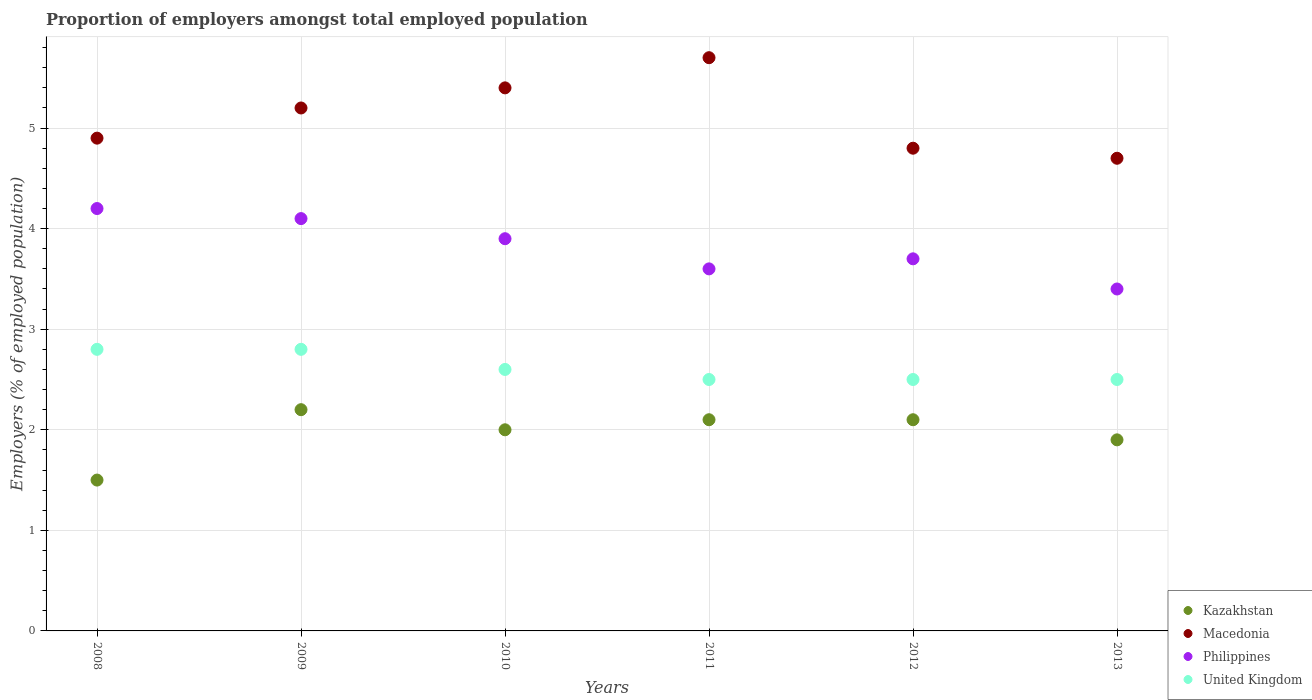How many different coloured dotlines are there?
Your answer should be very brief. 4. Is the number of dotlines equal to the number of legend labels?
Make the answer very short. Yes. What is the proportion of employers in United Kingdom in 2010?
Give a very brief answer. 2.6. Across all years, what is the maximum proportion of employers in Kazakhstan?
Provide a succinct answer. 2.2. Across all years, what is the minimum proportion of employers in United Kingdom?
Keep it short and to the point. 2.5. In which year was the proportion of employers in Kazakhstan maximum?
Your answer should be compact. 2009. What is the total proportion of employers in United Kingdom in the graph?
Keep it short and to the point. 15.7. What is the difference between the proportion of employers in Macedonia in 2011 and that in 2013?
Your answer should be very brief. 1. What is the difference between the proportion of employers in United Kingdom in 2013 and the proportion of employers in Philippines in 2009?
Your answer should be compact. -1.6. What is the average proportion of employers in Philippines per year?
Keep it short and to the point. 3.82. In the year 2008, what is the difference between the proportion of employers in Kazakhstan and proportion of employers in Macedonia?
Keep it short and to the point. -3.4. In how many years, is the proportion of employers in Philippines greater than 1.6 %?
Your response must be concise. 6. What is the ratio of the proportion of employers in Philippines in 2008 to that in 2012?
Offer a terse response. 1.14. What is the difference between the highest and the second highest proportion of employers in Macedonia?
Your response must be concise. 0.3. What is the difference between the highest and the lowest proportion of employers in Macedonia?
Your response must be concise. 1. In how many years, is the proportion of employers in Kazakhstan greater than the average proportion of employers in Kazakhstan taken over all years?
Make the answer very short. 4. Is the sum of the proportion of employers in Macedonia in 2008 and 2011 greater than the maximum proportion of employers in Philippines across all years?
Ensure brevity in your answer.  Yes. Is it the case that in every year, the sum of the proportion of employers in Macedonia and proportion of employers in United Kingdom  is greater than the sum of proportion of employers in Kazakhstan and proportion of employers in Philippines?
Provide a succinct answer. No. Does the proportion of employers in Kazakhstan monotonically increase over the years?
Ensure brevity in your answer.  No. Is the proportion of employers in United Kingdom strictly greater than the proportion of employers in Kazakhstan over the years?
Offer a very short reply. Yes. Is the proportion of employers in Macedonia strictly less than the proportion of employers in United Kingdom over the years?
Provide a succinct answer. No. What is the difference between two consecutive major ticks on the Y-axis?
Offer a terse response. 1. Where does the legend appear in the graph?
Your answer should be compact. Bottom right. What is the title of the graph?
Provide a succinct answer. Proportion of employers amongst total employed population. What is the label or title of the X-axis?
Keep it short and to the point. Years. What is the label or title of the Y-axis?
Offer a very short reply. Employers (% of employed population). What is the Employers (% of employed population) of Macedonia in 2008?
Offer a terse response. 4.9. What is the Employers (% of employed population) in Philippines in 2008?
Offer a terse response. 4.2. What is the Employers (% of employed population) in United Kingdom in 2008?
Your answer should be very brief. 2.8. What is the Employers (% of employed population) in Kazakhstan in 2009?
Provide a succinct answer. 2.2. What is the Employers (% of employed population) of Macedonia in 2009?
Provide a short and direct response. 5.2. What is the Employers (% of employed population) of Philippines in 2009?
Make the answer very short. 4.1. What is the Employers (% of employed population) of United Kingdom in 2009?
Keep it short and to the point. 2.8. What is the Employers (% of employed population) of Kazakhstan in 2010?
Your answer should be very brief. 2. What is the Employers (% of employed population) in Macedonia in 2010?
Your response must be concise. 5.4. What is the Employers (% of employed population) in Philippines in 2010?
Ensure brevity in your answer.  3.9. What is the Employers (% of employed population) in United Kingdom in 2010?
Your answer should be very brief. 2.6. What is the Employers (% of employed population) of Kazakhstan in 2011?
Ensure brevity in your answer.  2.1. What is the Employers (% of employed population) in Macedonia in 2011?
Your response must be concise. 5.7. What is the Employers (% of employed population) in Philippines in 2011?
Your answer should be compact. 3.6. What is the Employers (% of employed population) of United Kingdom in 2011?
Provide a succinct answer. 2.5. What is the Employers (% of employed population) in Kazakhstan in 2012?
Your response must be concise. 2.1. What is the Employers (% of employed population) of Macedonia in 2012?
Provide a short and direct response. 4.8. What is the Employers (% of employed population) of Philippines in 2012?
Provide a short and direct response. 3.7. What is the Employers (% of employed population) of Kazakhstan in 2013?
Your answer should be compact. 1.9. What is the Employers (% of employed population) of Macedonia in 2013?
Ensure brevity in your answer.  4.7. What is the Employers (% of employed population) of Philippines in 2013?
Keep it short and to the point. 3.4. What is the Employers (% of employed population) of United Kingdom in 2013?
Your answer should be compact. 2.5. Across all years, what is the maximum Employers (% of employed population) of Kazakhstan?
Make the answer very short. 2.2. Across all years, what is the maximum Employers (% of employed population) of Macedonia?
Your answer should be compact. 5.7. Across all years, what is the maximum Employers (% of employed population) of Philippines?
Keep it short and to the point. 4.2. Across all years, what is the maximum Employers (% of employed population) of United Kingdom?
Provide a succinct answer. 2.8. Across all years, what is the minimum Employers (% of employed population) of Kazakhstan?
Provide a succinct answer. 1.5. Across all years, what is the minimum Employers (% of employed population) in Macedonia?
Make the answer very short. 4.7. Across all years, what is the minimum Employers (% of employed population) in Philippines?
Ensure brevity in your answer.  3.4. Across all years, what is the minimum Employers (% of employed population) in United Kingdom?
Give a very brief answer. 2.5. What is the total Employers (% of employed population) in Kazakhstan in the graph?
Provide a short and direct response. 11.8. What is the total Employers (% of employed population) of Macedonia in the graph?
Provide a succinct answer. 30.7. What is the total Employers (% of employed population) of Philippines in the graph?
Ensure brevity in your answer.  22.9. What is the difference between the Employers (% of employed population) in United Kingdom in 2008 and that in 2009?
Provide a succinct answer. 0. What is the difference between the Employers (% of employed population) of Kazakhstan in 2008 and that in 2010?
Offer a terse response. -0.5. What is the difference between the Employers (% of employed population) of Macedonia in 2008 and that in 2010?
Keep it short and to the point. -0.5. What is the difference between the Employers (% of employed population) of United Kingdom in 2008 and that in 2010?
Make the answer very short. 0.2. What is the difference between the Employers (% of employed population) in Macedonia in 2008 and that in 2011?
Your answer should be very brief. -0.8. What is the difference between the Employers (% of employed population) of Philippines in 2008 and that in 2011?
Make the answer very short. 0.6. What is the difference between the Employers (% of employed population) of United Kingdom in 2008 and that in 2011?
Make the answer very short. 0.3. What is the difference between the Employers (% of employed population) of Kazakhstan in 2008 and that in 2013?
Keep it short and to the point. -0.4. What is the difference between the Employers (% of employed population) in United Kingdom in 2008 and that in 2013?
Your answer should be compact. 0.3. What is the difference between the Employers (% of employed population) of Kazakhstan in 2009 and that in 2010?
Offer a terse response. 0.2. What is the difference between the Employers (% of employed population) in Macedonia in 2009 and that in 2010?
Keep it short and to the point. -0.2. What is the difference between the Employers (% of employed population) in Philippines in 2009 and that in 2010?
Your answer should be very brief. 0.2. What is the difference between the Employers (% of employed population) in United Kingdom in 2009 and that in 2010?
Make the answer very short. 0.2. What is the difference between the Employers (% of employed population) of Philippines in 2009 and that in 2011?
Keep it short and to the point. 0.5. What is the difference between the Employers (% of employed population) in Macedonia in 2009 and that in 2012?
Make the answer very short. 0.4. What is the difference between the Employers (% of employed population) of Philippines in 2009 and that in 2012?
Your answer should be compact. 0.4. What is the difference between the Employers (% of employed population) of Kazakhstan in 2009 and that in 2013?
Make the answer very short. 0.3. What is the difference between the Employers (% of employed population) in Kazakhstan in 2010 and that in 2011?
Your answer should be compact. -0.1. What is the difference between the Employers (% of employed population) of Macedonia in 2010 and that in 2012?
Provide a succinct answer. 0.6. What is the difference between the Employers (% of employed population) of United Kingdom in 2010 and that in 2012?
Your answer should be compact. 0.1. What is the difference between the Employers (% of employed population) of Kazakhstan in 2010 and that in 2013?
Provide a succinct answer. 0.1. What is the difference between the Employers (% of employed population) of Macedonia in 2010 and that in 2013?
Your answer should be compact. 0.7. What is the difference between the Employers (% of employed population) of United Kingdom in 2010 and that in 2013?
Offer a very short reply. 0.1. What is the difference between the Employers (% of employed population) of Kazakhstan in 2011 and that in 2012?
Provide a succinct answer. 0. What is the difference between the Employers (% of employed population) in Kazakhstan in 2011 and that in 2013?
Make the answer very short. 0.2. What is the difference between the Employers (% of employed population) of Kazakhstan in 2012 and that in 2013?
Offer a very short reply. 0.2. What is the difference between the Employers (% of employed population) of Kazakhstan in 2008 and the Employers (% of employed population) of Macedonia in 2009?
Keep it short and to the point. -3.7. What is the difference between the Employers (% of employed population) in Kazakhstan in 2008 and the Employers (% of employed population) in Philippines in 2009?
Provide a succinct answer. -2.6. What is the difference between the Employers (% of employed population) of Kazakhstan in 2008 and the Employers (% of employed population) of United Kingdom in 2009?
Your answer should be very brief. -1.3. What is the difference between the Employers (% of employed population) of Macedonia in 2008 and the Employers (% of employed population) of Philippines in 2009?
Your response must be concise. 0.8. What is the difference between the Employers (% of employed population) in Macedonia in 2008 and the Employers (% of employed population) in United Kingdom in 2009?
Keep it short and to the point. 2.1. What is the difference between the Employers (% of employed population) of Kazakhstan in 2008 and the Employers (% of employed population) of Macedonia in 2010?
Your answer should be compact. -3.9. What is the difference between the Employers (% of employed population) of Kazakhstan in 2008 and the Employers (% of employed population) of United Kingdom in 2010?
Offer a very short reply. -1.1. What is the difference between the Employers (% of employed population) of Kazakhstan in 2008 and the Employers (% of employed population) of Macedonia in 2011?
Provide a succinct answer. -4.2. What is the difference between the Employers (% of employed population) in Kazakhstan in 2008 and the Employers (% of employed population) in United Kingdom in 2011?
Give a very brief answer. -1. What is the difference between the Employers (% of employed population) of Kazakhstan in 2008 and the Employers (% of employed population) of Philippines in 2012?
Make the answer very short. -2.2. What is the difference between the Employers (% of employed population) of Macedonia in 2008 and the Employers (% of employed population) of United Kingdom in 2012?
Provide a short and direct response. 2.4. What is the difference between the Employers (% of employed population) of Philippines in 2008 and the Employers (% of employed population) of United Kingdom in 2012?
Your answer should be very brief. 1.7. What is the difference between the Employers (% of employed population) of Kazakhstan in 2008 and the Employers (% of employed population) of Macedonia in 2013?
Your response must be concise. -3.2. What is the difference between the Employers (% of employed population) of Kazakhstan in 2008 and the Employers (% of employed population) of Philippines in 2013?
Your answer should be very brief. -1.9. What is the difference between the Employers (% of employed population) in Kazakhstan in 2009 and the Employers (% of employed population) in Philippines in 2010?
Ensure brevity in your answer.  -1.7. What is the difference between the Employers (% of employed population) in Macedonia in 2009 and the Employers (% of employed population) in Philippines in 2010?
Offer a terse response. 1.3. What is the difference between the Employers (% of employed population) in Macedonia in 2009 and the Employers (% of employed population) in United Kingdom in 2010?
Offer a terse response. 2.6. What is the difference between the Employers (% of employed population) in Kazakhstan in 2009 and the Employers (% of employed population) in Macedonia in 2011?
Provide a short and direct response. -3.5. What is the difference between the Employers (% of employed population) of Kazakhstan in 2009 and the Employers (% of employed population) of Philippines in 2011?
Your answer should be very brief. -1.4. What is the difference between the Employers (% of employed population) in Kazakhstan in 2009 and the Employers (% of employed population) in United Kingdom in 2011?
Provide a short and direct response. -0.3. What is the difference between the Employers (% of employed population) of Macedonia in 2009 and the Employers (% of employed population) of United Kingdom in 2011?
Keep it short and to the point. 2.7. What is the difference between the Employers (% of employed population) in Philippines in 2009 and the Employers (% of employed population) in United Kingdom in 2011?
Your response must be concise. 1.6. What is the difference between the Employers (% of employed population) in Kazakhstan in 2009 and the Employers (% of employed population) in Macedonia in 2012?
Offer a very short reply. -2.6. What is the difference between the Employers (% of employed population) of Kazakhstan in 2009 and the Employers (% of employed population) of United Kingdom in 2012?
Offer a very short reply. -0.3. What is the difference between the Employers (% of employed population) in Macedonia in 2009 and the Employers (% of employed population) in United Kingdom in 2012?
Offer a terse response. 2.7. What is the difference between the Employers (% of employed population) of Philippines in 2009 and the Employers (% of employed population) of United Kingdom in 2012?
Provide a short and direct response. 1.6. What is the difference between the Employers (% of employed population) in Kazakhstan in 2009 and the Employers (% of employed population) in Philippines in 2013?
Provide a succinct answer. -1.2. What is the difference between the Employers (% of employed population) of Macedonia in 2009 and the Employers (% of employed population) of Philippines in 2013?
Ensure brevity in your answer.  1.8. What is the difference between the Employers (% of employed population) of Philippines in 2009 and the Employers (% of employed population) of United Kingdom in 2013?
Provide a succinct answer. 1.6. What is the difference between the Employers (% of employed population) of Kazakhstan in 2010 and the Employers (% of employed population) of Macedonia in 2011?
Keep it short and to the point. -3.7. What is the difference between the Employers (% of employed population) in Kazakhstan in 2010 and the Employers (% of employed population) in United Kingdom in 2011?
Keep it short and to the point. -0.5. What is the difference between the Employers (% of employed population) of Kazakhstan in 2010 and the Employers (% of employed population) of Macedonia in 2012?
Give a very brief answer. -2.8. What is the difference between the Employers (% of employed population) in Kazakhstan in 2010 and the Employers (% of employed population) in United Kingdom in 2012?
Provide a short and direct response. -0.5. What is the difference between the Employers (% of employed population) in Macedonia in 2010 and the Employers (% of employed population) in Philippines in 2012?
Keep it short and to the point. 1.7. What is the difference between the Employers (% of employed population) of Macedonia in 2010 and the Employers (% of employed population) of United Kingdom in 2012?
Your response must be concise. 2.9. What is the difference between the Employers (% of employed population) of Kazakhstan in 2010 and the Employers (% of employed population) of Philippines in 2013?
Offer a terse response. -1.4. What is the difference between the Employers (% of employed population) of Kazakhstan in 2010 and the Employers (% of employed population) of United Kingdom in 2013?
Offer a very short reply. -0.5. What is the difference between the Employers (% of employed population) of Macedonia in 2010 and the Employers (% of employed population) of Philippines in 2013?
Your response must be concise. 2. What is the difference between the Employers (% of employed population) of Macedonia in 2010 and the Employers (% of employed population) of United Kingdom in 2013?
Provide a succinct answer. 2.9. What is the difference between the Employers (% of employed population) of Philippines in 2010 and the Employers (% of employed population) of United Kingdom in 2013?
Give a very brief answer. 1.4. What is the difference between the Employers (% of employed population) in Kazakhstan in 2011 and the Employers (% of employed population) in Macedonia in 2012?
Provide a succinct answer. -2.7. What is the difference between the Employers (% of employed population) of Kazakhstan in 2011 and the Employers (% of employed population) of Philippines in 2012?
Your response must be concise. -1.6. What is the difference between the Employers (% of employed population) of Kazakhstan in 2011 and the Employers (% of employed population) of United Kingdom in 2012?
Offer a very short reply. -0.4. What is the difference between the Employers (% of employed population) of Macedonia in 2011 and the Employers (% of employed population) of United Kingdom in 2012?
Keep it short and to the point. 3.2. What is the difference between the Employers (% of employed population) in Kazakhstan in 2011 and the Employers (% of employed population) in Macedonia in 2013?
Ensure brevity in your answer.  -2.6. What is the difference between the Employers (% of employed population) in Kazakhstan in 2012 and the Employers (% of employed population) in Macedonia in 2013?
Your answer should be very brief. -2.6. What is the difference between the Employers (% of employed population) in Kazakhstan in 2012 and the Employers (% of employed population) in Philippines in 2013?
Keep it short and to the point. -1.3. What is the difference between the Employers (% of employed population) of Macedonia in 2012 and the Employers (% of employed population) of Philippines in 2013?
Your answer should be compact. 1.4. What is the average Employers (% of employed population) of Kazakhstan per year?
Provide a succinct answer. 1.97. What is the average Employers (% of employed population) of Macedonia per year?
Give a very brief answer. 5.12. What is the average Employers (% of employed population) in Philippines per year?
Your answer should be compact. 3.82. What is the average Employers (% of employed population) in United Kingdom per year?
Your response must be concise. 2.62. In the year 2008, what is the difference between the Employers (% of employed population) in Macedonia and Employers (% of employed population) in United Kingdom?
Make the answer very short. 2.1. In the year 2009, what is the difference between the Employers (% of employed population) in Kazakhstan and Employers (% of employed population) in United Kingdom?
Ensure brevity in your answer.  -0.6. In the year 2009, what is the difference between the Employers (% of employed population) in Macedonia and Employers (% of employed population) in Philippines?
Provide a succinct answer. 1.1. In the year 2009, what is the difference between the Employers (% of employed population) of Philippines and Employers (% of employed population) of United Kingdom?
Keep it short and to the point. 1.3. In the year 2010, what is the difference between the Employers (% of employed population) of Kazakhstan and Employers (% of employed population) of Philippines?
Give a very brief answer. -1.9. In the year 2010, what is the difference between the Employers (% of employed population) of Macedonia and Employers (% of employed population) of United Kingdom?
Your response must be concise. 2.8. In the year 2011, what is the difference between the Employers (% of employed population) in Kazakhstan and Employers (% of employed population) in Macedonia?
Keep it short and to the point. -3.6. In the year 2011, what is the difference between the Employers (% of employed population) in Kazakhstan and Employers (% of employed population) in Philippines?
Offer a very short reply. -1.5. In the year 2011, what is the difference between the Employers (% of employed population) in Kazakhstan and Employers (% of employed population) in United Kingdom?
Provide a short and direct response. -0.4. In the year 2011, what is the difference between the Employers (% of employed population) of Macedonia and Employers (% of employed population) of United Kingdom?
Your answer should be very brief. 3.2. In the year 2012, what is the difference between the Employers (% of employed population) of Kazakhstan and Employers (% of employed population) of Philippines?
Provide a succinct answer. -1.6. In the year 2013, what is the difference between the Employers (% of employed population) in Kazakhstan and Employers (% of employed population) in Philippines?
Make the answer very short. -1.5. In the year 2013, what is the difference between the Employers (% of employed population) of Macedonia and Employers (% of employed population) of Philippines?
Ensure brevity in your answer.  1.3. In the year 2013, what is the difference between the Employers (% of employed population) in Macedonia and Employers (% of employed population) in United Kingdom?
Give a very brief answer. 2.2. In the year 2013, what is the difference between the Employers (% of employed population) of Philippines and Employers (% of employed population) of United Kingdom?
Give a very brief answer. 0.9. What is the ratio of the Employers (% of employed population) in Kazakhstan in 2008 to that in 2009?
Your answer should be compact. 0.68. What is the ratio of the Employers (% of employed population) of Macedonia in 2008 to that in 2009?
Offer a terse response. 0.94. What is the ratio of the Employers (% of employed population) in Philippines in 2008 to that in 2009?
Provide a short and direct response. 1.02. What is the ratio of the Employers (% of employed population) of United Kingdom in 2008 to that in 2009?
Ensure brevity in your answer.  1. What is the ratio of the Employers (% of employed population) in Kazakhstan in 2008 to that in 2010?
Keep it short and to the point. 0.75. What is the ratio of the Employers (% of employed population) of Macedonia in 2008 to that in 2010?
Offer a terse response. 0.91. What is the ratio of the Employers (% of employed population) of Philippines in 2008 to that in 2010?
Keep it short and to the point. 1.08. What is the ratio of the Employers (% of employed population) of United Kingdom in 2008 to that in 2010?
Make the answer very short. 1.08. What is the ratio of the Employers (% of employed population) of Macedonia in 2008 to that in 2011?
Give a very brief answer. 0.86. What is the ratio of the Employers (% of employed population) in United Kingdom in 2008 to that in 2011?
Offer a very short reply. 1.12. What is the ratio of the Employers (% of employed population) of Kazakhstan in 2008 to that in 2012?
Give a very brief answer. 0.71. What is the ratio of the Employers (% of employed population) of Macedonia in 2008 to that in 2012?
Your answer should be compact. 1.02. What is the ratio of the Employers (% of employed population) in Philippines in 2008 to that in 2012?
Keep it short and to the point. 1.14. What is the ratio of the Employers (% of employed population) in United Kingdom in 2008 to that in 2012?
Your answer should be very brief. 1.12. What is the ratio of the Employers (% of employed population) of Kazakhstan in 2008 to that in 2013?
Make the answer very short. 0.79. What is the ratio of the Employers (% of employed population) of Macedonia in 2008 to that in 2013?
Give a very brief answer. 1.04. What is the ratio of the Employers (% of employed population) of Philippines in 2008 to that in 2013?
Make the answer very short. 1.24. What is the ratio of the Employers (% of employed population) of United Kingdom in 2008 to that in 2013?
Offer a terse response. 1.12. What is the ratio of the Employers (% of employed population) of Kazakhstan in 2009 to that in 2010?
Your response must be concise. 1.1. What is the ratio of the Employers (% of employed population) in Macedonia in 2009 to that in 2010?
Offer a terse response. 0.96. What is the ratio of the Employers (% of employed population) in Philippines in 2009 to that in 2010?
Your answer should be very brief. 1.05. What is the ratio of the Employers (% of employed population) in Kazakhstan in 2009 to that in 2011?
Provide a short and direct response. 1.05. What is the ratio of the Employers (% of employed population) of Macedonia in 2009 to that in 2011?
Provide a short and direct response. 0.91. What is the ratio of the Employers (% of employed population) in Philippines in 2009 to that in 2011?
Provide a succinct answer. 1.14. What is the ratio of the Employers (% of employed population) of United Kingdom in 2009 to that in 2011?
Your answer should be very brief. 1.12. What is the ratio of the Employers (% of employed population) of Kazakhstan in 2009 to that in 2012?
Offer a very short reply. 1.05. What is the ratio of the Employers (% of employed population) in Philippines in 2009 to that in 2012?
Provide a short and direct response. 1.11. What is the ratio of the Employers (% of employed population) in United Kingdom in 2009 to that in 2012?
Your answer should be very brief. 1.12. What is the ratio of the Employers (% of employed population) in Kazakhstan in 2009 to that in 2013?
Provide a short and direct response. 1.16. What is the ratio of the Employers (% of employed population) in Macedonia in 2009 to that in 2013?
Your answer should be very brief. 1.11. What is the ratio of the Employers (% of employed population) of Philippines in 2009 to that in 2013?
Your answer should be very brief. 1.21. What is the ratio of the Employers (% of employed population) in United Kingdom in 2009 to that in 2013?
Keep it short and to the point. 1.12. What is the ratio of the Employers (% of employed population) of Kazakhstan in 2010 to that in 2011?
Your answer should be compact. 0.95. What is the ratio of the Employers (% of employed population) in Philippines in 2010 to that in 2011?
Give a very brief answer. 1.08. What is the ratio of the Employers (% of employed population) in United Kingdom in 2010 to that in 2011?
Your answer should be compact. 1.04. What is the ratio of the Employers (% of employed population) in Macedonia in 2010 to that in 2012?
Your response must be concise. 1.12. What is the ratio of the Employers (% of employed population) of Philippines in 2010 to that in 2012?
Offer a very short reply. 1.05. What is the ratio of the Employers (% of employed population) in Kazakhstan in 2010 to that in 2013?
Your answer should be compact. 1.05. What is the ratio of the Employers (% of employed population) in Macedonia in 2010 to that in 2013?
Offer a very short reply. 1.15. What is the ratio of the Employers (% of employed population) of Philippines in 2010 to that in 2013?
Give a very brief answer. 1.15. What is the ratio of the Employers (% of employed population) in Kazakhstan in 2011 to that in 2012?
Make the answer very short. 1. What is the ratio of the Employers (% of employed population) of Macedonia in 2011 to that in 2012?
Offer a very short reply. 1.19. What is the ratio of the Employers (% of employed population) in United Kingdom in 2011 to that in 2012?
Your answer should be compact. 1. What is the ratio of the Employers (% of employed population) of Kazakhstan in 2011 to that in 2013?
Ensure brevity in your answer.  1.11. What is the ratio of the Employers (% of employed population) of Macedonia in 2011 to that in 2013?
Your response must be concise. 1.21. What is the ratio of the Employers (% of employed population) of Philippines in 2011 to that in 2013?
Provide a succinct answer. 1.06. What is the ratio of the Employers (% of employed population) of Kazakhstan in 2012 to that in 2013?
Provide a succinct answer. 1.11. What is the ratio of the Employers (% of employed population) of Macedonia in 2012 to that in 2013?
Offer a terse response. 1.02. What is the ratio of the Employers (% of employed population) of Philippines in 2012 to that in 2013?
Keep it short and to the point. 1.09. What is the difference between the highest and the second highest Employers (% of employed population) in Kazakhstan?
Provide a succinct answer. 0.1. What is the difference between the highest and the second highest Employers (% of employed population) in Macedonia?
Offer a very short reply. 0.3. What is the difference between the highest and the second highest Employers (% of employed population) of United Kingdom?
Ensure brevity in your answer.  0. What is the difference between the highest and the lowest Employers (% of employed population) in Kazakhstan?
Your answer should be compact. 0.7. What is the difference between the highest and the lowest Employers (% of employed population) of Macedonia?
Your answer should be very brief. 1. What is the difference between the highest and the lowest Employers (% of employed population) in Philippines?
Provide a short and direct response. 0.8. What is the difference between the highest and the lowest Employers (% of employed population) of United Kingdom?
Give a very brief answer. 0.3. 